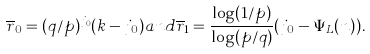<formula> <loc_0><loc_0><loc_500><loc_500>\overline { r } _ { 0 } = ( q / p ) ^ { j _ { 0 } } ( k - j _ { 0 } ) a n d \overline { r } _ { 1 } = \frac { \log ( 1 / p ) } { \log ( p / q ) } ( j _ { 0 } - \Psi _ { L } ( n ) ) .</formula> 